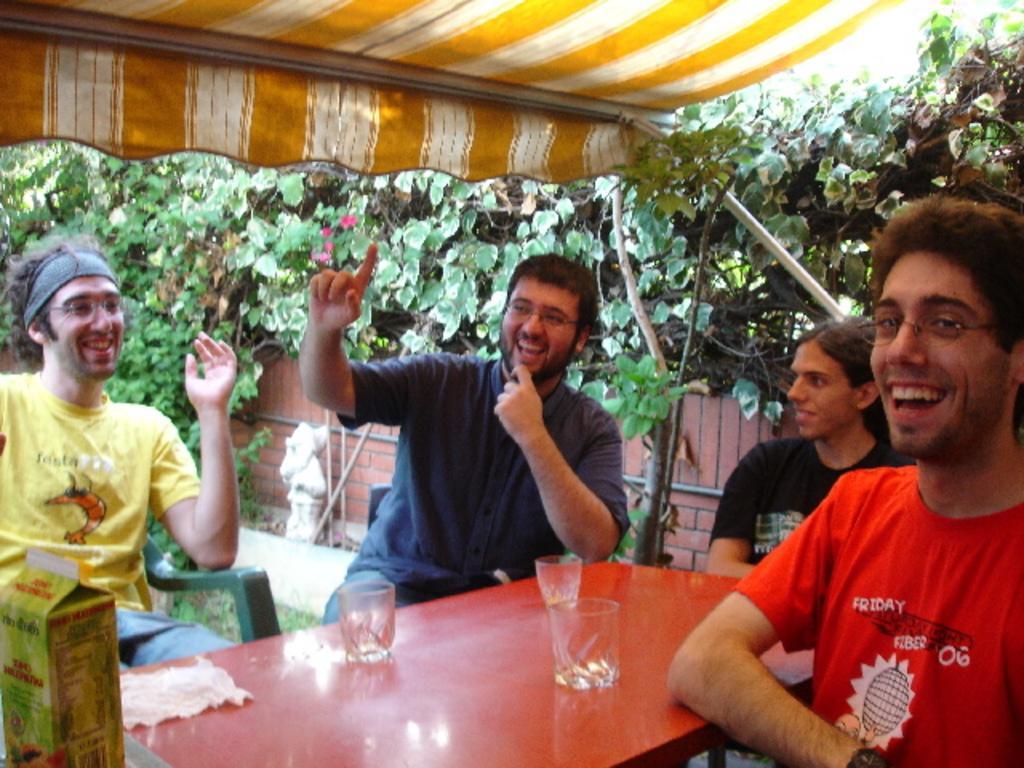Describe this image in one or two sentences. In this picture we can see a few glasses, box and a cloth on the table. We can see a group of people sitting on the chair. We can see a statue, tent and some plants in the background. 